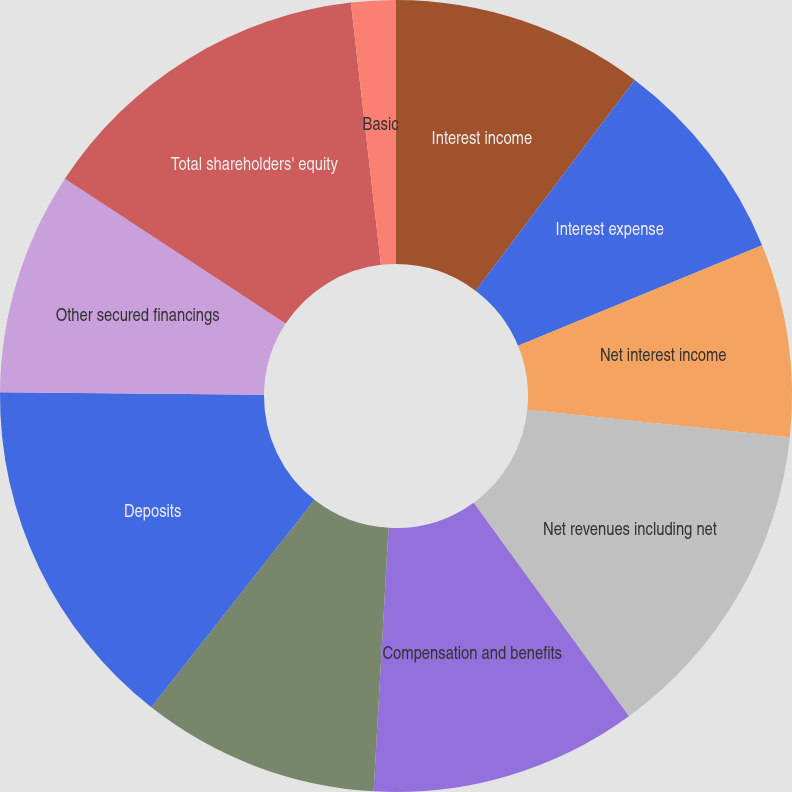<chart> <loc_0><loc_0><loc_500><loc_500><pie_chart><fcel>Interest income<fcel>Interest expense<fcel>Net interest income<fcel>Net revenues including net<fcel>Compensation and benefits<fcel>Non-compensation expenses<fcel>Deposits<fcel>Other secured financings<fcel>Total shareholders' equity<fcel>Basic<nl><fcel>10.3%<fcel>8.48%<fcel>7.88%<fcel>13.33%<fcel>10.91%<fcel>9.7%<fcel>14.55%<fcel>9.09%<fcel>13.94%<fcel>1.82%<nl></chart> 